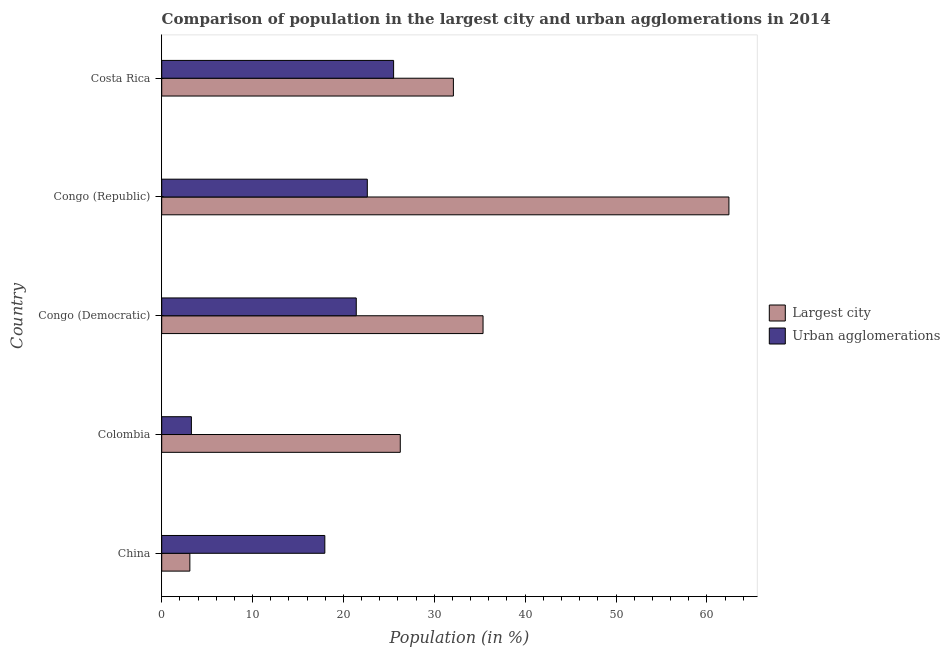Are the number of bars per tick equal to the number of legend labels?
Keep it short and to the point. Yes. What is the label of the 5th group of bars from the top?
Keep it short and to the point. China. In how many cases, is the number of bars for a given country not equal to the number of legend labels?
Make the answer very short. 0. What is the population in the largest city in China?
Your answer should be compact. 3.1. Across all countries, what is the maximum population in the largest city?
Make the answer very short. 62.43. Across all countries, what is the minimum population in urban agglomerations?
Ensure brevity in your answer.  3.27. In which country was the population in urban agglomerations maximum?
Provide a short and direct response. Costa Rica. What is the total population in urban agglomerations in the graph?
Offer a terse response. 90.78. What is the difference between the population in urban agglomerations in Colombia and that in Congo (Democratic)?
Offer a very short reply. -18.14. What is the difference between the population in the largest city in China and the population in urban agglomerations in Congo (Republic)?
Your answer should be very brief. -19.53. What is the average population in urban agglomerations per country?
Make the answer very short. 18.16. What is the difference between the population in urban agglomerations and population in the largest city in Congo (Democratic)?
Provide a short and direct response. -13.96. In how many countries, is the population in urban agglomerations greater than 4 %?
Keep it short and to the point. 4. What is the ratio of the population in urban agglomerations in China to that in Congo (Democratic)?
Your answer should be compact. 0.84. Is the population in urban agglomerations in Colombia less than that in Congo (Democratic)?
Offer a terse response. Yes. What is the difference between the highest and the second highest population in the largest city?
Your response must be concise. 27.06. What is the difference between the highest and the lowest population in the largest city?
Your answer should be very brief. 59.33. What does the 2nd bar from the top in Congo (Republic) represents?
Ensure brevity in your answer.  Largest city. What does the 2nd bar from the bottom in China represents?
Ensure brevity in your answer.  Urban agglomerations. Are the values on the major ticks of X-axis written in scientific E-notation?
Offer a very short reply. No. Does the graph contain any zero values?
Make the answer very short. No. Does the graph contain grids?
Offer a terse response. No. Where does the legend appear in the graph?
Offer a terse response. Center right. How are the legend labels stacked?
Your answer should be very brief. Vertical. What is the title of the graph?
Your answer should be very brief. Comparison of population in the largest city and urban agglomerations in 2014. Does "Male labor force" appear as one of the legend labels in the graph?
Offer a very short reply. No. What is the label or title of the Y-axis?
Offer a very short reply. Country. What is the Population (in %) of Largest city in China?
Make the answer very short. 3.1. What is the Population (in %) of Urban agglomerations in China?
Offer a very short reply. 17.95. What is the Population (in %) of Largest city in Colombia?
Your response must be concise. 26.26. What is the Population (in %) in Urban agglomerations in Colombia?
Offer a terse response. 3.27. What is the Population (in %) in Largest city in Congo (Democratic)?
Provide a succinct answer. 35.37. What is the Population (in %) of Urban agglomerations in Congo (Democratic)?
Your answer should be very brief. 21.41. What is the Population (in %) of Largest city in Congo (Republic)?
Make the answer very short. 62.43. What is the Population (in %) in Urban agglomerations in Congo (Republic)?
Ensure brevity in your answer.  22.63. What is the Population (in %) in Largest city in Costa Rica?
Provide a short and direct response. 32.1. What is the Population (in %) in Urban agglomerations in Costa Rica?
Ensure brevity in your answer.  25.52. Across all countries, what is the maximum Population (in %) in Largest city?
Give a very brief answer. 62.43. Across all countries, what is the maximum Population (in %) of Urban agglomerations?
Make the answer very short. 25.52. Across all countries, what is the minimum Population (in %) in Largest city?
Your answer should be very brief. 3.1. Across all countries, what is the minimum Population (in %) in Urban agglomerations?
Your answer should be very brief. 3.27. What is the total Population (in %) in Largest city in the graph?
Your answer should be very brief. 159.26. What is the total Population (in %) of Urban agglomerations in the graph?
Your answer should be compact. 90.78. What is the difference between the Population (in %) in Largest city in China and that in Colombia?
Offer a very short reply. -23.16. What is the difference between the Population (in %) in Urban agglomerations in China and that in Colombia?
Provide a short and direct response. 14.69. What is the difference between the Population (in %) of Largest city in China and that in Congo (Democratic)?
Give a very brief answer. -32.27. What is the difference between the Population (in %) of Urban agglomerations in China and that in Congo (Democratic)?
Provide a short and direct response. -3.46. What is the difference between the Population (in %) in Largest city in China and that in Congo (Republic)?
Offer a terse response. -59.33. What is the difference between the Population (in %) in Urban agglomerations in China and that in Congo (Republic)?
Your answer should be very brief. -4.68. What is the difference between the Population (in %) in Largest city in China and that in Costa Rica?
Offer a very short reply. -29.01. What is the difference between the Population (in %) of Urban agglomerations in China and that in Costa Rica?
Provide a short and direct response. -7.57. What is the difference between the Population (in %) in Largest city in Colombia and that in Congo (Democratic)?
Your response must be concise. -9.11. What is the difference between the Population (in %) of Urban agglomerations in Colombia and that in Congo (Democratic)?
Your answer should be very brief. -18.15. What is the difference between the Population (in %) in Largest city in Colombia and that in Congo (Republic)?
Your response must be concise. -36.17. What is the difference between the Population (in %) in Urban agglomerations in Colombia and that in Congo (Republic)?
Your response must be concise. -19.36. What is the difference between the Population (in %) in Largest city in Colombia and that in Costa Rica?
Your answer should be compact. -5.85. What is the difference between the Population (in %) of Urban agglomerations in Colombia and that in Costa Rica?
Make the answer very short. -22.26. What is the difference between the Population (in %) of Largest city in Congo (Democratic) and that in Congo (Republic)?
Offer a terse response. -27.06. What is the difference between the Population (in %) of Urban agglomerations in Congo (Democratic) and that in Congo (Republic)?
Provide a short and direct response. -1.22. What is the difference between the Population (in %) of Largest city in Congo (Democratic) and that in Costa Rica?
Ensure brevity in your answer.  3.26. What is the difference between the Population (in %) of Urban agglomerations in Congo (Democratic) and that in Costa Rica?
Ensure brevity in your answer.  -4.11. What is the difference between the Population (in %) in Largest city in Congo (Republic) and that in Costa Rica?
Your answer should be very brief. 30.33. What is the difference between the Population (in %) of Urban agglomerations in Congo (Republic) and that in Costa Rica?
Offer a terse response. -2.89. What is the difference between the Population (in %) of Largest city in China and the Population (in %) of Urban agglomerations in Colombia?
Ensure brevity in your answer.  -0.17. What is the difference between the Population (in %) in Largest city in China and the Population (in %) in Urban agglomerations in Congo (Democratic)?
Provide a succinct answer. -18.32. What is the difference between the Population (in %) in Largest city in China and the Population (in %) in Urban agglomerations in Congo (Republic)?
Your answer should be very brief. -19.53. What is the difference between the Population (in %) of Largest city in China and the Population (in %) of Urban agglomerations in Costa Rica?
Ensure brevity in your answer.  -22.43. What is the difference between the Population (in %) of Largest city in Colombia and the Population (in %) of Urban agglomerations in Congo (Democratic)?
Provide a short and direct response. 4.85. What is the difference between the Population (in %) of Largest city in Colombia and the Population (in %) of Urban agglomerations in Congo (Republic)?
Offer a terse response. 3.63. What is the difference between the Population (in %) in Largest city in Colombia and the Population (in %) in Urban agglomerations in Costa Rica?
Offer a terse response. 0.74. What is the difference between the Population (in %) in Largest city in Congo (Democratic) and the Population (in %) in Urban agglomerations in Congo (Republic)?
Make the answer very short. 12.74. What is the difference between the Population (in %) of Largest city in Congo (Democratic) and the Population (in %) of Urban agglomerations in Costa Rica?
Provide a succinct answer. 9.84. What is the difference between the Population (in %) in Largest city in Congo (Republic) and the Population (in %) in Urban agglomerations in Costa Rica?
Keep it short and to the point. 36.91. What is the average Population (in %) in Largest city per country?
Give a very brief answer. 31.85. What is the average Population (in %) in Urban agglomerations per country?
Give a very brief answer. 18.16. What is the difference between the Population (in %) of Largest city and Population (in %) of Urban agglomerations in China?
Ensure brevity in your answer.  -14.86. What is the difference between the Population (in %) of Largest city and Population (in %) of Urban agglomerations in Colombia?
Ensure brevity in your answer.  22.99. What is the difference between the Population (in %) in Largest city and Population (in %) in Urban agglomerations in Congo (Democratic)?
Provide a succinct answer. 13.95. What is the difference between the Population (in %) in Largest city and Population (in %) in Urban agglomerations in Congo (Republic)?
Ensure brevity in your answer.  39.8. What is the difference between the Population (in %) in Largest city and Population (in %) in Urban agglomerations in Costa Rica?
Provide a short and direct response. 6.58. What is the ratio of the Population (in %) in Largest city in China to that in Colombia?
Your answer should be compact. 0.12. What is the ratio of the Population (in %) of Urban agglomerations in China to that in Colombia?
Your answer should be very brief. 5.49. What is the ratio of the Population (in %) of Largest city in China to that in Congo (Democratic)?
Provide a succinct answer. 0.09. What is the ratio of the Population (in %) in Urban agglomerations in China to that in Congo (Democratic)?
Offer a terse response. 0.84. What is the ratio of the Population (in %) of Largest city in China to that in Congo (Republic)?
Give a very brief answer. 0.05. What is the ratio of the Population (in %) in Urban agglomerations in China to that in Congo (Republic)?
Give a very brief answer. 0.79. What is the ratio of the Population (in %) of Largest city in China to that in Costa Rica?
Make the answer very short. 0.1. What is the ratio of the Population (in %) in Urban agglomerations in China to that in Costa Rica?
Provide a short and direct response. 0.7. What is the ratio of the Population (in %) in Largest city in Colombia to that in Congo (Democratic)?
Ensure brevity in your answer.  0.74. What is the ratio of the Population (in %) of Urban agglomerations in Colombia to that in Congo (Democratic)?
Keep it short and to the point. 0.15. What is the ratio of the Population (in %) of Largest city in Colombia to that in Congo (Republic)?
Give a very brief answer. 0.42. What is the ratio of the Population (in %) of Urban agglomerations in Colombia to that in Congo (Republic)?
Provide a short and direct response. 0.14. What is the ratio of the Population (in %) of Largest city in Colombia to that in Costa Rica?
Ensure brevity in your answer.  0.82. What is the ratio of the Population (in %) in Urban agglomerations in Colombia to that in Costa Rica?
Offer a very short reply. 0.13. What is the ratio of the Population (in %) of Largest city in Congo (Democratic) to that in Congo (Republic)?
Offer a terse response. 0.57. What is the ratio of the Population (in %) of Urban agglomerations in Congo (Democratic) to that in Congo (Republic)?
Make the answer very short. 0.95. What is the ratio of the Population (in %) of Largest city in Congo (Democratic) to that in Costa Rica?
Offer a very short reply. 1.1. What is the ratio of the Population (in %) in Urban agglomerations in Congo (Democratic) to that in Costa Rica?
Your answer should be compact. 0.84. What is the ratio of the Population (in %) of Largest city in Congo (Republic) to that in Costa Rica?
Offer a very short reply. 1.94. What is the ratio of the Population (in %) in Urban agglomerations in Congo (Republic) to that in Costa Rica?
Make the answer very short. 0.89. What is the difference between the highest and the second highest Population (in %) in Largest city?
Your answer should be compact. 27.06. What is the difference between the highest and the second highest Population (in %) in Urban agglomerations?
Your response must be concise. 2.89. What is the difference between the highest and the lowest Population (in %) in Largest city?
Make the answer very short. 59.33. What is the difference between the highest and the lowest Population (in %) in Urban agglomerations?
Make the answer very short. 22.26. 